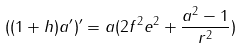<formula> <loc_0><loc_0><loc_500><loc_500>( ( 1 + h ) a ^ { \prime } ) ^ { \prime } = a ( 2 f ^ { 2 } e ^ { 2 } + \frac { a ^ { 2 } - 1 } { r ^ { 2 } } )</formula> 